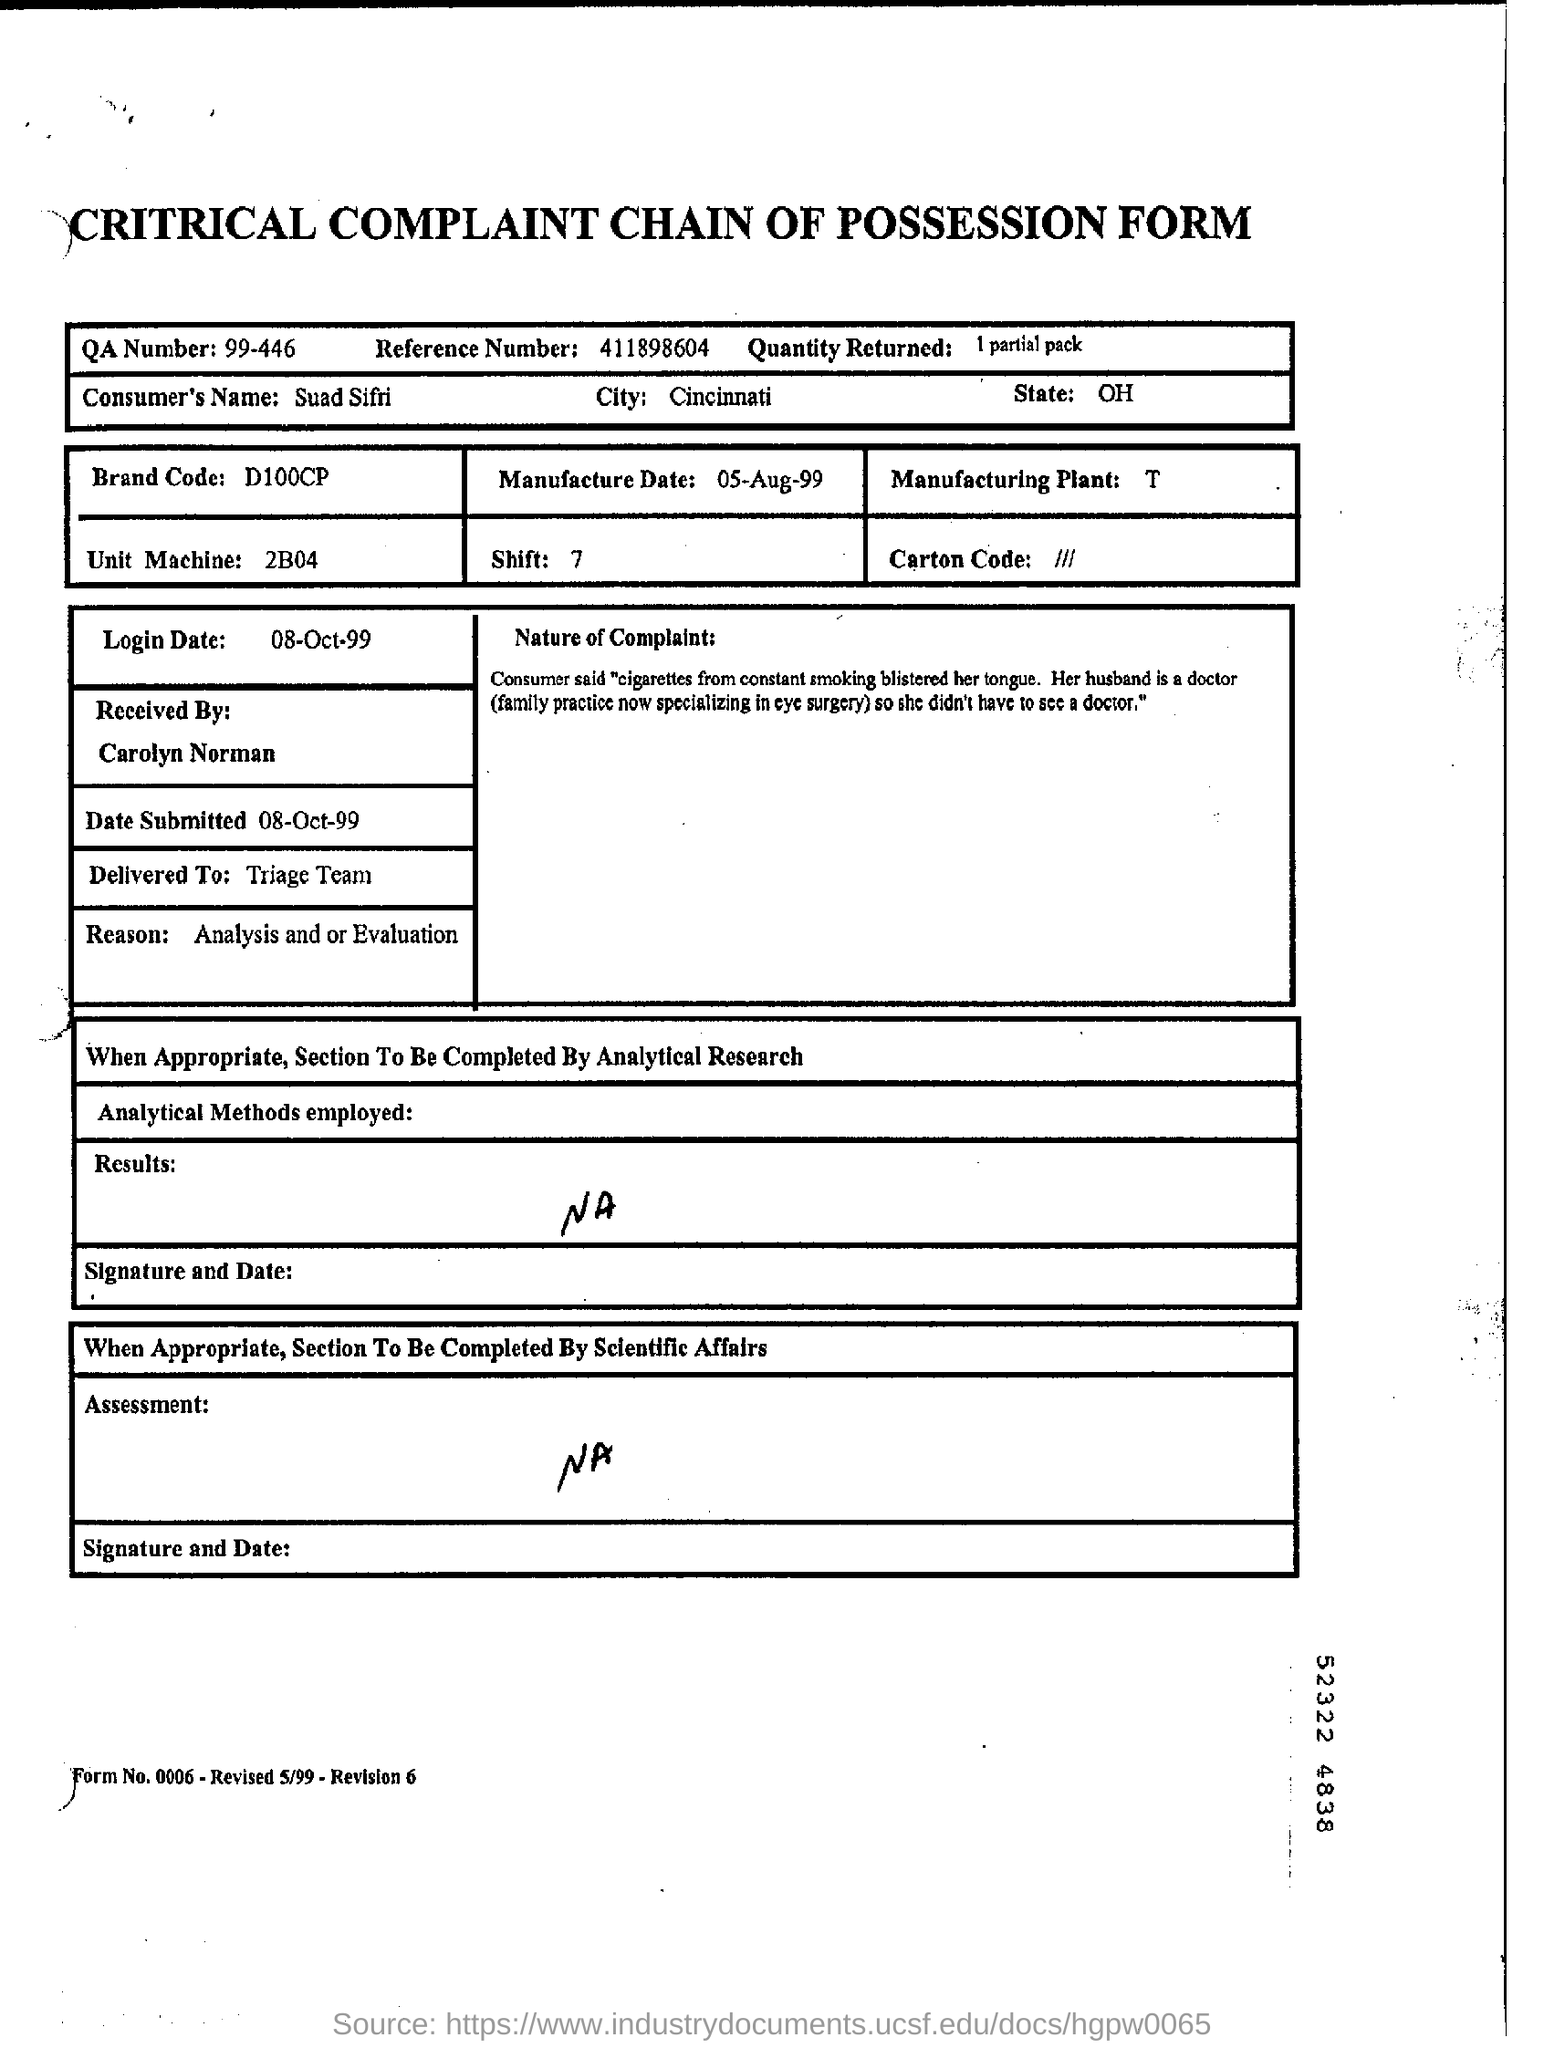What is QA number?
Your answer should be compact. 99-446. What  is brand code?
Your answer should be very brief. D100CP. What is mentioned as Reason?
Offer a terse response. Analysis and or Evaluation. What is assessment?
Provide a short and direct response. NA. 